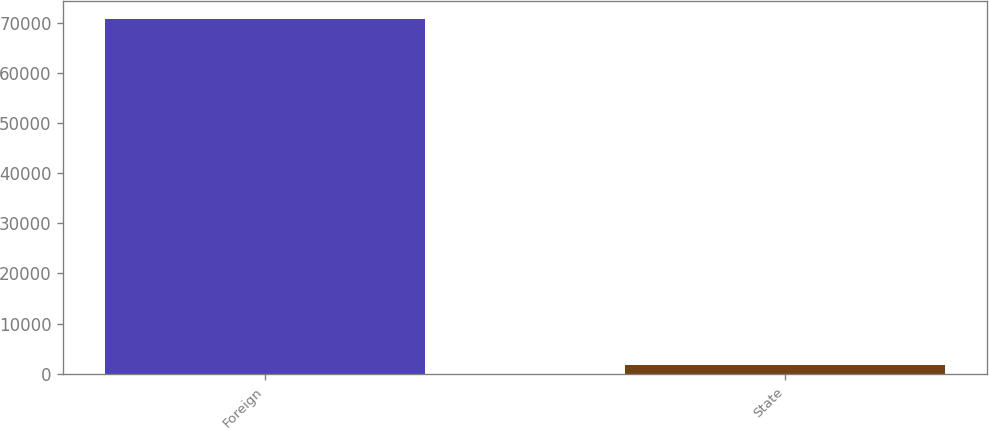<chart> <loc_0><loc_0><loc_500><loc_500><bar_chart><fcel>Foreign<fcel>State<nl><fcel>70882<fcel>1770<nl></chart> 